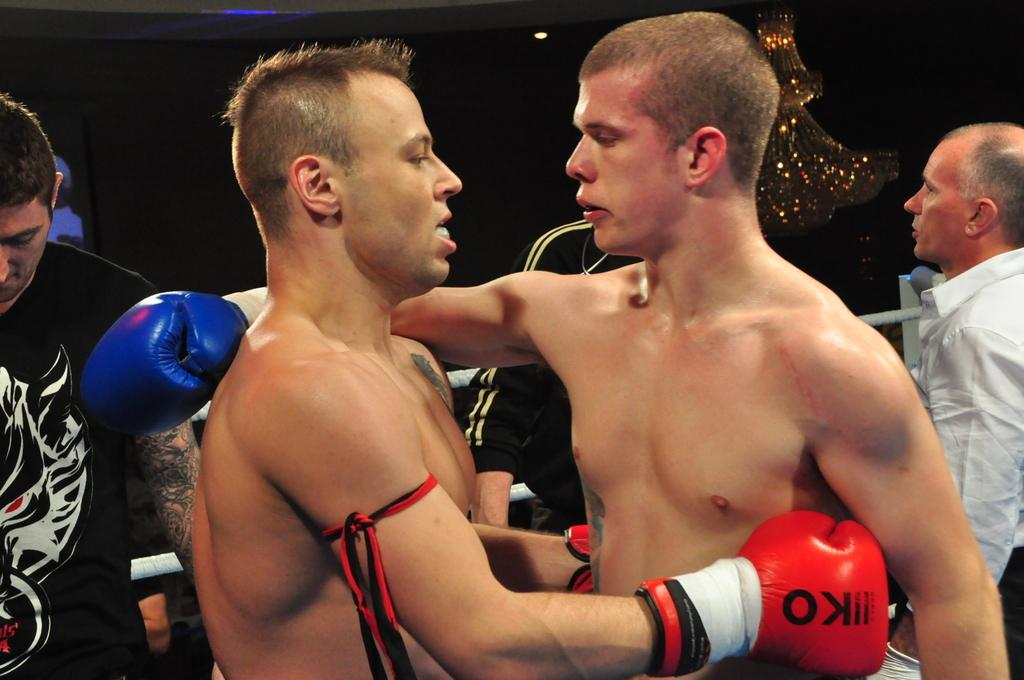<image>
Offer a succinct explanation of the picture presented. Two boxers embrace, and one of them is wearing a glove that says KO on it. 